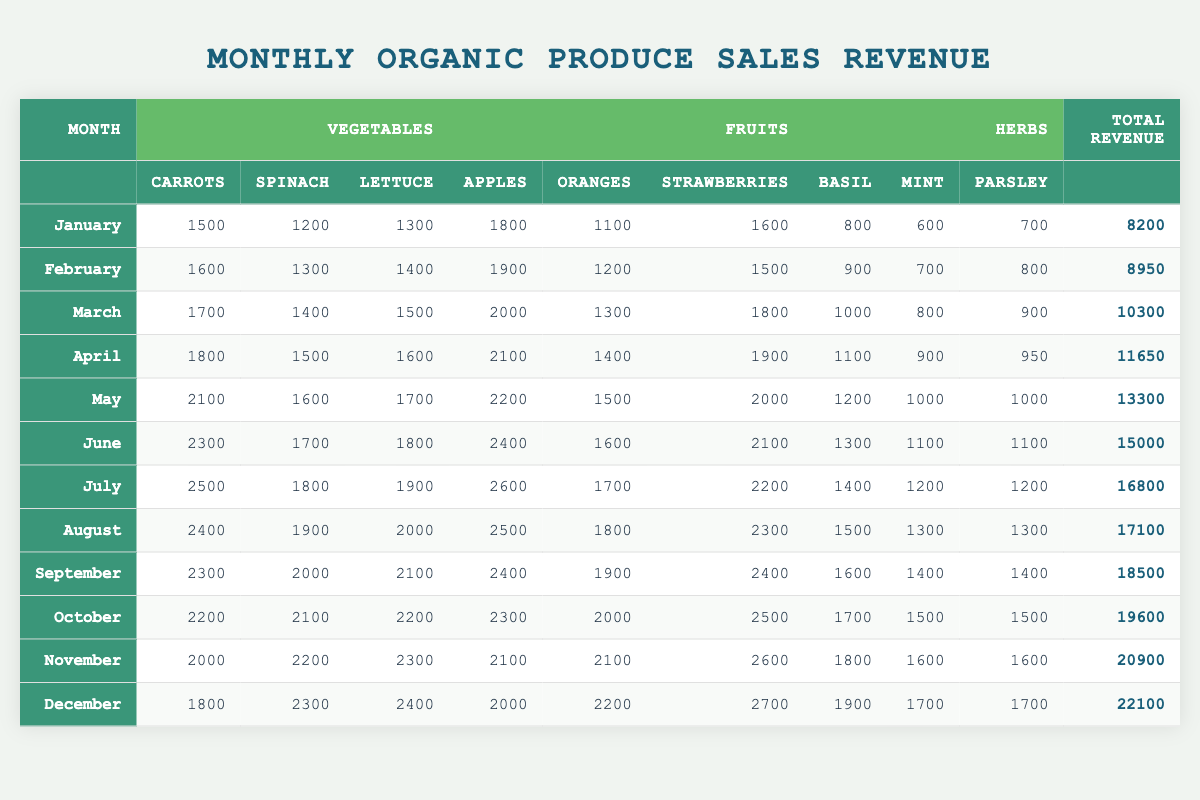What was the total revenue in August? The total revenue for August is clearly listed in the last column of the table. It states that the total revenue for August was 17100.
Answer: 17100 Which month had the highest total revenue? By checking the Total Revenue column, December has the highest total revenue listed, which is 22100.
Answer: December How much revenue did Strawberries generate in October? To find the revenue for Strawberries in October, we look at the October row, and the value for Strawberries is 2500.
Answer: 2500 What was the difference in total revenue between January and June? January has a total revenue of 8200, and June has 15000. To find the difference, subtract January's total from June's: 15000 - 8200 = 6800.
Answer: 6800 What is the average revenue for the months from March to May? For March, the total revenue is 10300, for April it is 11650, and for May it is 13300. Add these three revenues: 10300 + 11650 + 13300 = 35250. Divide that sum by 3 (the number of months) to find the average: 35250 / 3 = 11750.
Answer: 11750 Did the revenue from Herbs increase throughout the year? By examining the Herbs categories each month, we see that the total revenue from Herbs does not consistently increase but fluctuates. For instance, in January the total was 2100, but in June it was also 3300. However, further examination shows that there were dips in certain months. Thus, no, the revenue did not consistently increase.
Answer: No During which month did Apples generate the most revenue, and how much was it? The revenue generated from Apples is the highest in July with a value of 2600, which can be found in the July row under the Apples column.
Answer: July, 2600 What was the total revenue for the first half of the year (January to June)? The total revenue for each of the first six months is summed: January (8200) + February (8950) + March (10300) + April (11650) + May (13300) + June (15000) = 8200 + 8950 + 10300 + 11650 + 13300 + 15000 = 82000.
Answer: 82000 Which vegetable had the lowest total sales revenue in November? By checking the vegetable sales figures for November, we find Carrots (2000), Spinach (2200), and Lettuce (2300). The lowest among these is Carrots with 2000.
Answer: Carrots How many total sales were generated from Fruits in September? In the September row, Apples generated 2400, Oranges 1900, and Strawberries 2400. The total from these three fruits is: 2400 + 1900 + 2400 = 6700.
Answer: 6700 